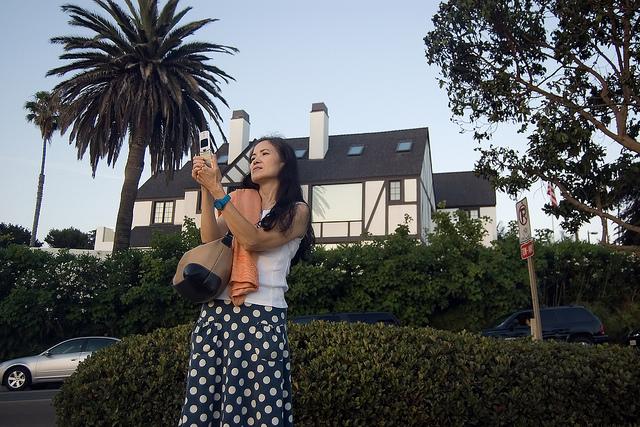What color is her hair?
Concise answer only. Black. How many people are there?
Concise answer only. 1. Is the woman in motion?
Concise answer only. No. Is this woman in a nature setting?
Keep it brief. No. What kind of pattern is on the woman's skirt?
Quick response, please. Polka dot. How many vehicles are in the background?
Concise answer only. 3. What is the lady doing?
Keep it brief. Taking picture. 